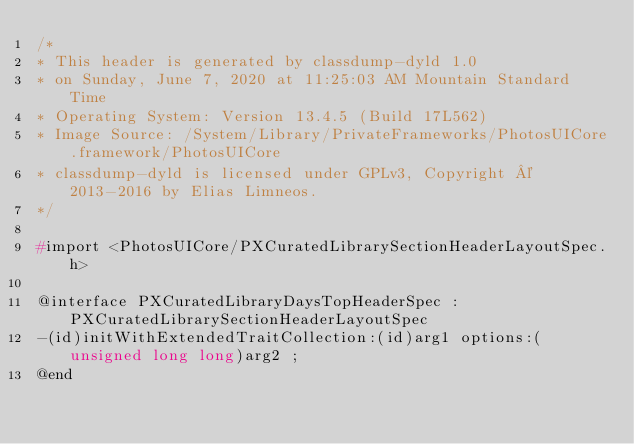Convert code to text. <code><loc_0><loc_0><loc_500><loc_500><_C_>/*
* This header is generated by classdump-dyld 1.0
* on Sunday, June 7, 2020 at 11:25:03 AM Mountain Standard Time
* Operating System: Version 13.4.5 (Build 17L562)
* Image Source: /System/Library/PrivateFrameworks/PhotosUICore.framework/PhotosUICore
* classdump-dyld is licensed under GPLv3, Copyright © 2013-2016 by Elias Limneos.
*/

#import <PhotosUICore/PXCuratedLibrarySectionHeaderLayoutSpec.h>

@interface PXCuratedLibraryDaysTopHeaderSpec : PXCuratedLibrarySectionHeaderLayoutSpec
-(id)initWithExtendedTraitCollection:(id)arg1 options:(unsigned long long)arg2 ;
@end

</code> 